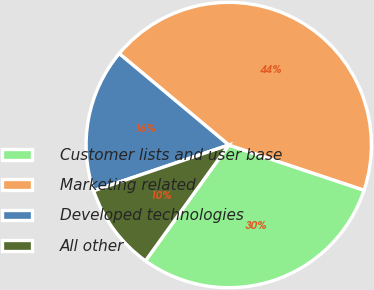Convert chart. <chart><loc_0><loc_0><loc_500><loc_500><pie_chart><fcel>Customer lists and user base<fcel>Marketing related<fcel>Developed technologies<fcel>All other<nl><fcel>29.79%<fcel>44.06%<fcel>16.27%<fcel>9.88%<nl></chart> 